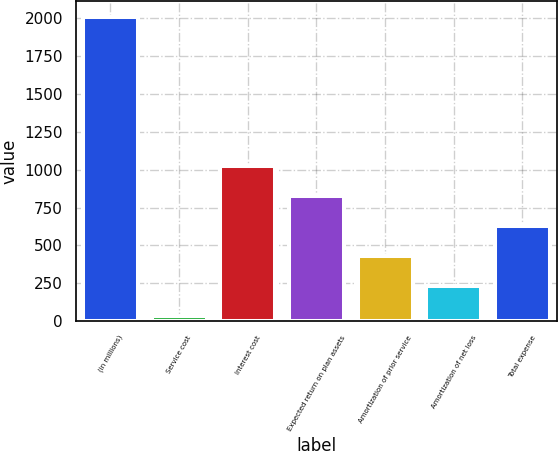Convert chart. <chart><loc_0><loc_0><loc_500><loc_500><bar_chart><fcel>(in millions)<fcel>Service cost<fcel>Interest cost<fcel>Expected return on plan assets<fcel>Amortization of prior service<fcel>Amortization of net loss<fcel>Total expense<nl><fcel>2010<fcel>35<fcel>1022.5<fcel>825<fcel>430<fcel>232.5<fcel>627.5<nl></chart> 